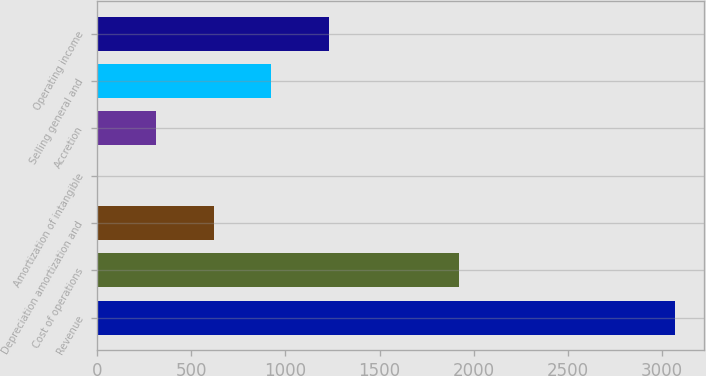Convert chart. <chart><loc_0><loc_0><loc_500><loc_500><bar_chart><fcel>Revenue<fcel>Cost of operations<fcel>Depreciation amortization and<fcel>Amortization of intangible<fcel>Accretion<fcel>Selling general and<fcel>Operating income<nl><fcel>3070.6<fcel>1924.4<fcel>619.72<fcel>7<fcel>313.36<fcel>926.08<fcel>1232.44<nl></chart> 